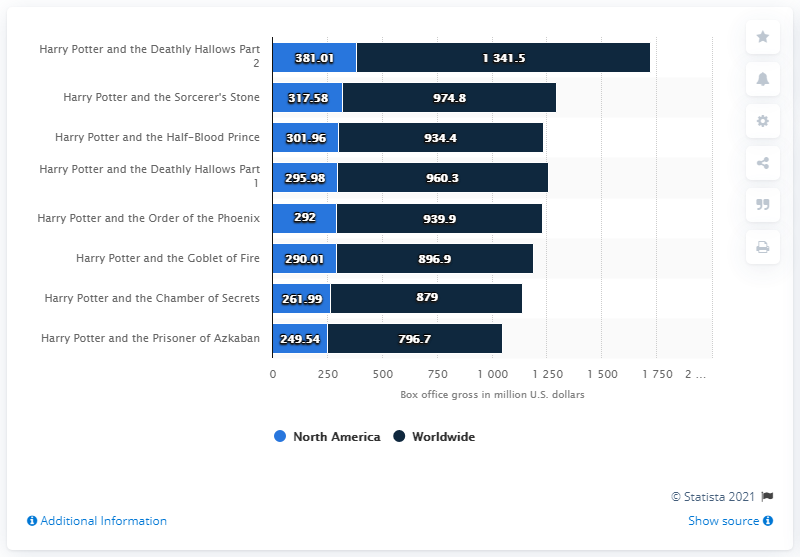List a handful of essential elements in this visual. The gross of Harry Potter and the Half-Blood Prince was approximately 301.96. The movie with the greatest disparity between revenue in North America and worldwide is "Harry Potter and the Deathly Hallows Part 2". The worldwide box office revenue of Harry Potter and the Goblet of Fire was 896.9 million U.S. dollars. 